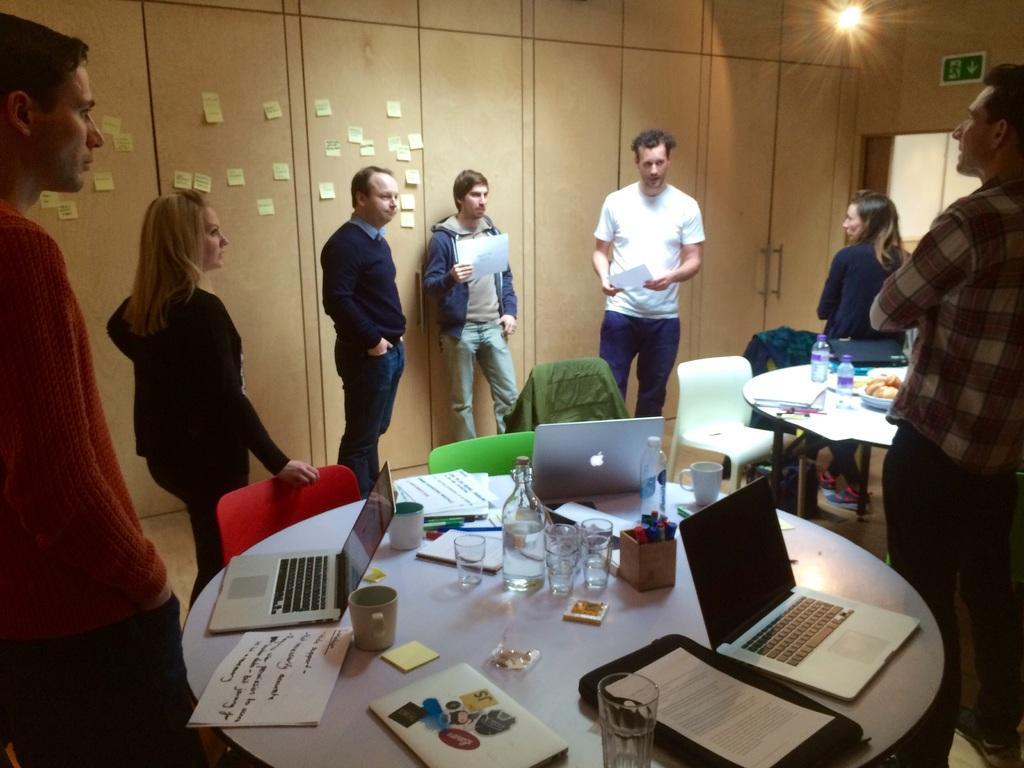Describe this image in one or two sentences. There is a group of people five boys and 2 girls. They are talking. One boy is holding a paper and another boy is talking something. The girl is holding a chair another girl is sitting on a table. Here is a table the above of the table like glass,laptop,papers,filed,cup and pen. We can see background there is a cupboard and light. 